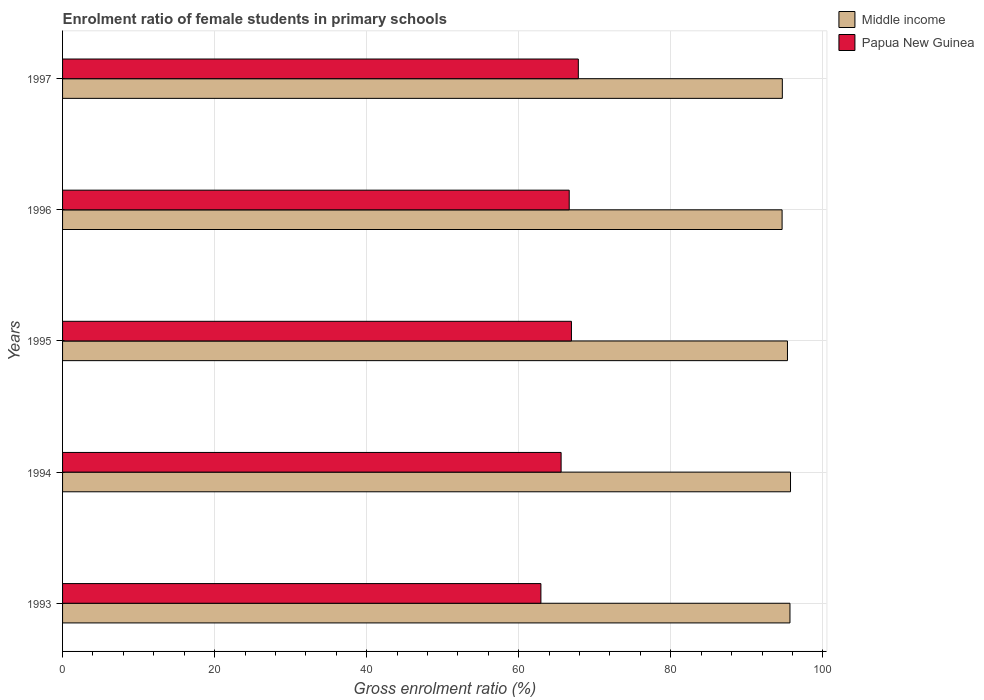How many groups of bars are there?
Ensure brevity in your answer.  5. Are the number of bars on each tick of the Y-axis equal?
Provide a succinct answer. Yes. How many bars are there on the 4th tick from the bottom?
Offer a very short reply. 2. What is the label of the 2nd group of bars from the top?
Offer a very short reply. 1996. What is the enrolment ratio of female students in primary schools in Papua New Guinea in 1997?
Provide a succinct answer. 67.84. Across all years, what is the maximum enrolment ratio of female students in primary schools in Middle income?
Offer a terse response. 95.75. Across all years, what is the minimum enrolment ratio of female students in primary schools in Middle income?
Your answer should be very brief. 94.64. In which year was the enrolment ratio of female students in primary schools in Middle income maximum?
Provide a short and direct response. 1994. What is the total enrolment ratio of female students in primary schools in Papua New Guinea in the graph?
Provide a succinct answer. 329.91. What is the difference between the enrolment ratio of female students in primary schools in Papua New Guinea in 1994 and that in 1996?
Your answer should be compact. -1.07. What is the difference between the enrolment ratio of female students in primary schools in Middle income in 1996 and the enrolment ratio of female students in primary schools in Papua New Guinea in 1997?
Provide a short and direct response. 26.8. What is the average enrolment ratio of female students in primary schools in Papua New Guinea per year?
Keep it short and to the point. 65.98. In the year 1995, what is the difference between the enrolment ratio of female students in primary schools in Middle income and enrolment ratio of female students in primary schools in Papua New Guinea?
Offer a terse response. 28.42. In how many years, is the enrolment ratio of female students in primary schools in Middle income greater than 8 %?
Your answer should be very brief. 5. What is the ratio of the enrolment ratio of female students in primary schools in Papua New Guinea in 1994 to that in 1995?
Your answer should be very brief. 0.98. Is the enrolment ratio of female students in primary schools in Papua New Guinea in 1995 less than that in 1996?
Give a very brief answer. No. Is the difference between the enrolment ratio of female students in primary schools in Middle income in 1994 and 1996 greater than the difference between the enrolment ratio of female students in primary schools in Papua New Guinea in 1994 and 1996?
Keep it short and to the point. Yes. What is the difference between the highest and the second highest enrolment ratio of female students in primary schools in Papua New Guinea?
Ensure brevity in your answer.  0.91. What is the difference between the highest and the lowest enrolment ratio of female students in primary schools in Papua New Guinea?
Provide a short and direct response. 4.92. In how many years, is the enrolment ratio of female students in primary schools in Papua New Guinea greater than the average enrolment ratio of female students in primary schools in Papua New Guinea taken over all years?
Provide a short and direct response. 3. Is the sum of the enrolment ratio of female students in primary schools in Papua New Guinea in 1993 and 1997 greater than the maximum enrolment ratio of female students in primary schools in Middle income across all years?
Your answer should be very brief. Yes. What does the 1st bar from the top in 1996 represents?
Make the answer very short. Papua New Guinea. Are all the bars in the graph horizontal?
Give a very brief answer. Yes. How many years are there in the graph?
Make the answer very short. 5. What is the difference between two consecutive major ticks on the X-axis?
Offer a terse response. 20. Are the values on the major ticks of X-axis written in scientific E-notation?
Offer a very short reply. No. How many legend labels are there?
Ensure brevity in your answer.  2. How are the legend labels stacked?
Your response must be concise. Vertical. What is the title of the graph?
Your response must be concise. Enrolment ratio of female students in primary schools. What is the label or title of the Y-axis?
Keep it short and to the point. Years. What is the Gross enrolment ratio (%) of Middle income in 1993?
Your answer should be compact. 95.68. What is the Gross enrolment ratio (%) in Papua New Guinea in 1993?
Ensure brevity in your answer.  62.92. What is the Gross enrolment ratio (%) of Middle income in 1994?
Your answer should be compact. 95.75. What is the Gross enrolment ratio (%) of Papua New Guinea in 1994?
Give a very brief answer. 65.58. What is the Gross enrolment ratio (%) in Middle income in 1995?
Offer a terse response. 95.35. What is the Gross enrolment ratio (%) of Papua New Guinea in 1995?
Offer a terse response. 66.93. What is the Gross enrolment ratio (%) in Middle income in 1996?
Your answer should be very brief. 94.64. What is the Gross enrolment ratio (%) of Papua New Guinea in 1996?
Make the answer very short. 66.64. What is the Gross enrolment ratio (%) in Middle income in 1997?
Offer a very short reply. 94.67. What is the Gross enrolment ratio (%) in Papua New Guinea in 1997?
Offer a very short reply. 67.84. Across all years, what is the maximum Gross enrolment ratio (%) in Middle income?
Your answer should be compact. 95.75. Across all years, what is the maximum Gross enrolment ratio (%) of Papua New Guinea?
Your answer should be compact. 67.84. Across all years, what is the minimum Gross enrolment ratio (%) of Middle income?
Your answer should be very brief. 94.64. Across all years, what is the minimum Gross enrolment ratio (%) in Papua New Guinea?
Provide a succinct answer. 62.92. What is the total Gross enrolment ratio (%) in Middle income in the graph?
Give a very brief answer. 476.09. What is the total Gross enrolment ratio (%) of Papua New Guinea in the graph?
Offer a terse response. 329.91. What is the difference between the Gross enrolment ratio (%) of Middle income in 1993 and that in 1994?
Give a very brief answer. -0.07. What is the difference between the Gross enrolment ratio (%) in Papua New Guinea in 1993 and that in 1994?
Give a very brief answer. -2.66. What is the difference between the Gross enrolment ratio (%) in Middle income in 1993 and that in 1995?
Your answer should be compact. 0.33. What is the difference between the Gross enrolment ratio (%) of Papua New Guinea in 1993 and that in 1995?
Keep it short and to the point. -4.02. What is the difference between the Gross enrolment ratio (%) in Middle income in 1993 and that in 1996?
Your response must be concise. 1.03. What is the difference between the Gross enrolment ratio (%) in Papua New Guinea in 1993 and that in 1996?
Your response must be concise. -3.72. What is the difference between the Gross enrolment ratio (%) in Papua New Guinea in 1993 and that in 1997?
Your answer should be compact. -4.92. What is the difference between the Gross enrolment ratio (%) of Middle income in 1994 and that in 1995?
Ensure brevity in your answer.  0.4. What is the difference between the Gross enrolment ratio (%) of Papua New Guinea in 1994 and that in 1995?
Give a very brief answer. -1.36. What is the difference between the Gross enrolment ratio (%) in Middle income in 1994 and that in 1996?
Your response must be concise. 1.11. What is the difference between the Gross enrolment ratio (%) in Papua New Guinea in 1994 and that in 1996?
Your answer should be very brief. -1.07. What is the difference between the Gross enrolment ratio (%) of Middle income in 1994 and that in 1997?
Ensure brevity in your answer.  1.08. What is the difference between the Gross enrolment ratio (%) in Papua New Guinea in 1994 and that in 1997?
Offer a very short reply. -2.26. What is the difference between the Gross enrolment ratio (%) in Middle income in 1995 and that in 1996?
Give a very brief answer. 0.71. What is the difference between the Gross enrolment ratio (%) in Papua New Guinea in 1995 and that in 1996?
Your answer should be very brief. 0.29. What is the difference between the Gross enrolment ratio (%) in Middle income in 1995 and that in 1997?
Offer a terse response. 0.68. What is the difference between the Gross enrolment ratio (%) of Papua New Guinea in 1995 and that in 1997?
Provide a short and direct response. -0.91. What is the difference between the Gross enrolment ratio (%) of Middle income in 1996 and that in 1997?
Offer a very short reply. -0.03. What is the difference between the Gross enrolment ratio (%) of Papua New Guinea in 1996 and that in 1997?
Ensure brevity in your answer.  -1.2. What is the difference between the Gross enrolment ratio (%) of Middle income in 1993 and the Gross enrolment ratio (%) of Papua New Guinea in 1994?
Make the answer very short. 30.1. What is the difference between the Gross enrolment ratio (%) in Middle income in 1993 and the Gross enrolment ratio (%) in Papua New Guinea in 1995?
Your answer should be very brief. 28.74. What is the difference between the Gross enrolment ratio (%) in Middle income in 1993 and the Gross enrolment ratio (%) in Papua New Guinea in 1996?
Keep it short and to the point. 29.04. What is the difference between the Gross enrolment ratio (%) of Middle income in 1993 and the Gross enrolment ratio (%) of Papua New Guinea in 1997?
Your response must be concise. 27.84. What is the difference between the Gross enrolment ratio (%) in Middle income in 1994 and the Gross enrolment ratio (%) in Papua New Guinea in 1995?
Offer a very short reply. 28.82. What is the difference between the Gross enrolment ratio (%) in Middle income in 1994 and the Gross enrolment ratio (%) in Papua New Guinea in 1996?
Provide a short and direct response. 29.11. What is the difference between the Gross enrolment ratio (%) of Middle income in 1994 and the Gross enrolment ratio (%) of Papua New Guinea in 1997?
Ensure brevity in your answer.  27.91. What is the difference between the Gross enrolment ratio (%) of Middle income in 1995 and the Gross enrolment ratio (%) of Papua New Guinea in 1996?
Make the answer very short. 28.71. What is the difference between the Gross enrolment ratio (%) in Middle income in 1995 and the Gross enrolment ratio (%) in Papua New Guinea in 1997?
Your answer should be very brief. 27.51. What is the difference between the Gross enrolment ratio (%) in Middle income in 1996 and the Gross enrolment ratio (%) in Papua New Guinea in 1997?
Ensure brevity in your answer.  26.8. What is the average Gross enrolment ratio (%) of Middle income per year?
Offer a very short reply. 95.22. What is the average Gross enrolment ratio (%) of Papua New Guinea per year?
Keep it short and to the point. 65.98. In the year 1993, what is the difference between the Gross enrolment ratio (%) of Middle income and Gross enrolment ratio (%) of Papua New Guinea?
Ensure brevity in your answer.  32.76. In the year 1994, what is the difference between the Gross enrolment ratio (%) of Middle income and Gross enrolment ratio (%) of Papua New Guinea?
Offer a terse response. 30.17. In the year 1995, what is the difference between the Gross enrolment ratio (%) in Middle income and Gross enrolment ratio (%) in Papua New Guinea?
Ensure brevity in your answer.  28.42. In the year 1996, what is the difference between the Gross enrolment ratio (%) of Middle income and Gross enrolment ratio (%) of Papua New Guinea?
Provide a succinct answer. 28. In the year 1997, what is the difference between the Gross enrolment ratio (%) of Middle income and Gross enrolment ratio (%) of Papua New Guinea?
Your answer should be very brief. 26.83. What is the ratio of the Gross enrolment ratio (%) in Papua New Guinea in 1993 to that in 1994?
Offer a terse response. 0.96. What is the ratio of the Gross enrolment ratio (%) in Papua New Guinea in 1993 to that in 1995?
Provide a succinct answer. 0.94. What is the ratio of the Gross enrolment ratio (%) in Middle income in 1993 to that in 1996?
Your answer should be very brief. 1.01. What is the ratio of the Gross enrolment ratio (%) in Papua New Guinea in 1993 to that in 1996?
Provide a short and direct response. 0.94. What is the ratio of the Gross enrolment ratio (%) in Middle income in 1993 to that in 1997?
Your answer should be compact. 1.01. What is the ratio of the Gross enrolment ratio (%) in Papua New Guinea in 1993 to that in 1997?
Your response must be concise. 0.93. What is the ratio of the Gross enrolment ratio (%) in Papua New Guinea in 1994 to that in 1995?
Ensure brevity in your answer.  0.98. What is the ratio of the Gross enrolment ratio (%) in Middle income in 1994 to that in 1996?
Provide a short and direct response. 1.01. What is the ratio of the Gross enrolment ratio (%) of Papua New Guinea in 1994 to that in 1996?
Give a very brief answer. 0.98. What is the ratio of the Gross enrolment ratio (%) of Middle income in 1994 to that in 1997?
Keep it short and to the point. 1.01. What is the ratio of the Gross enrolment ratio (%) in Papua New Guinea in 1994 to that in 1997?
Provide a short and direct response. 0.97. What is the ratio of the Gross enrolment ratio (%) in Middle income in 1995 to that in 1996?
Ensure brevity in your answer.  1.01. What is the ratio of the Gross enrolment ratio (%) of Papua New Guinea in 1995 to that in 1996?
Make the answer very short. 1. What is the ratio of the Gross enrolment ratio (%) of Middle income in 1995 to that in 1997?
Ensure brevity in your answer.  1.01. What is the ratio of the Gross enrolment ratio (%) of Papua New Guinea in 1995 to that in 1997?
Provide a succinct answer. 0.99. What is the ratio of the Gross enrolment ratio (%) of Middle income in 1996 to that in 1997?
Make the answer very short. 1. What is the ratio of the Gross enrolment ratio (%) in Papua New Guinea in 1996 to that in 1997?
Give a very brief answer. 0.98. What is the difference between the highest and the second highest Gross enrolment ratio (%) in Middle income?
Your answer should be compact. 0.07. What is the difference between the highest and the second highest Gross enrolment ratio (%) of Papua New Guinea?
Offer a terse response. 0.91. What is the difference between the highest and the lowest Gross enrolment ratio (%) of Middle income?
Provide a succinct answer. 1.11. What is the difference between the highest and the lowest Gross enrolment ratio (%) of Papua New Guinea?
Give a very brief answer. 4.92. 